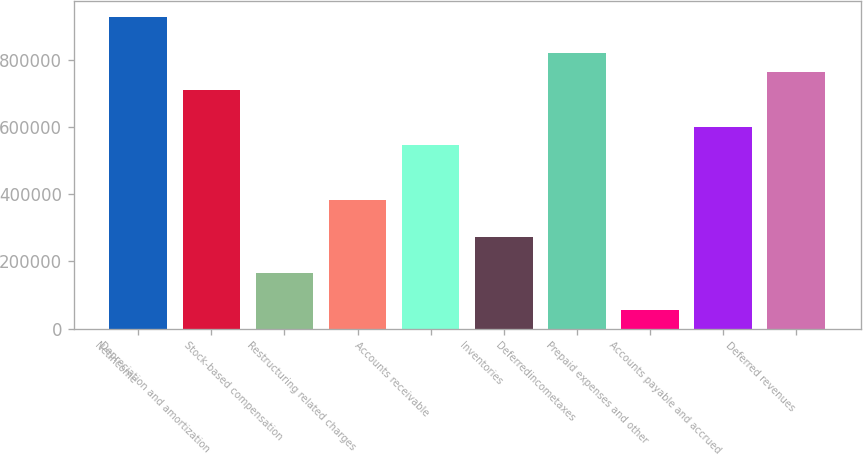Convert chart. <chart><loc_0><loc_0><loc_500><loc_500><bar_chart><fcel>Netincome<fcel>Depreciation and amortization<fcel>Stock-based compensation<fcel>Restructuring related charges<fcel>Accounts receivable<fcel>Inventories<fcel>Deferredincometaxes<fcel>Prepaid expenses and other<fcel>Accounts payable and accrued<fcel>Deferred revenues<nl><fcel>928275<fcel>710065<fcel>164541<fcel>382751<fcel>546408<fcel>273646<fcel>819170<fcel>55436.4<fcel>600960<fcel>764618<nl></chart> 